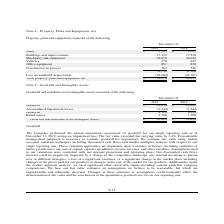From Lifeway Foods's financial document, What is the value of buildings and improvements in 2018 and 2019 respectively? The document shows two values: 17,520 and 17,332. From the document: "Buildings and improvements 17,332 17,520 Buildings and improvements 17,332 17,520..." Also, What is the value of machinery and equipment in 2018 and 2019 respectively? The document shows two values: 29,692 and 30,670. From the document: "Machinery and equipment 30,670 29,692 Machinery and equipment 30,670 29,692..." Also, What is the value of vehicles in 2018 and 2019 respectively? The document shows two values: 937 and 778. From the document: "Vehicles 778 937 Vehicles 778 937..." Also, can you calculate: What is the average value of vehicles for 2018 and 2019? To answer this question, I need to perform calculations using the financial data. The calculation is: (778+937)/2, which equals 857.5. This is based on the information: "Vehicles 778 937 Vehicles 778 937..." The key data points involved are: 778, 937. Also, can you calculate: What is the change in the value of land between 2018 and 2019? Based on the calculation: 1,565-1,747, the result is -182. This is based on the information: "Land $ 1,565 $ 1,747 Land $ 1,565 $ 1,747..." The key data points involved are: 1,565, 1,747. Additionally, Which year has a higher total property, plant and equipment, net value? According to the financial document, 2018. The relevant text states: "2019 2018..." 